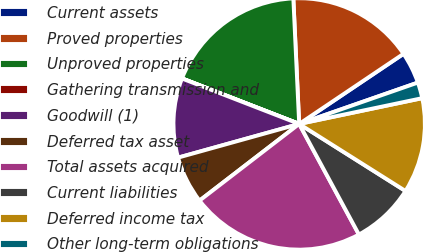<chart> <loc_0><loc_0><loc_500><loc_500><pie_chart><fcel>Current assets<fcel>Proved properties<fcel>Unproved properties<fcel>Gathering transmission and<fcel>Goodwill (1)<fcel>Deferred tax asset<fcel>Total assets acquired<fcel>Current liabilities<fcel>Deferred income tax<fcel>Other long-term obligations<nl><fcel>4.08%<fcel>16.32%<fcel>18.36%<fcel>0.01%<fcel>10.2%<fcel>6.12%<fcel>22.44%<fcel>8.16%<fcel>12.24%<fcel>2.05%<nl></chart> 